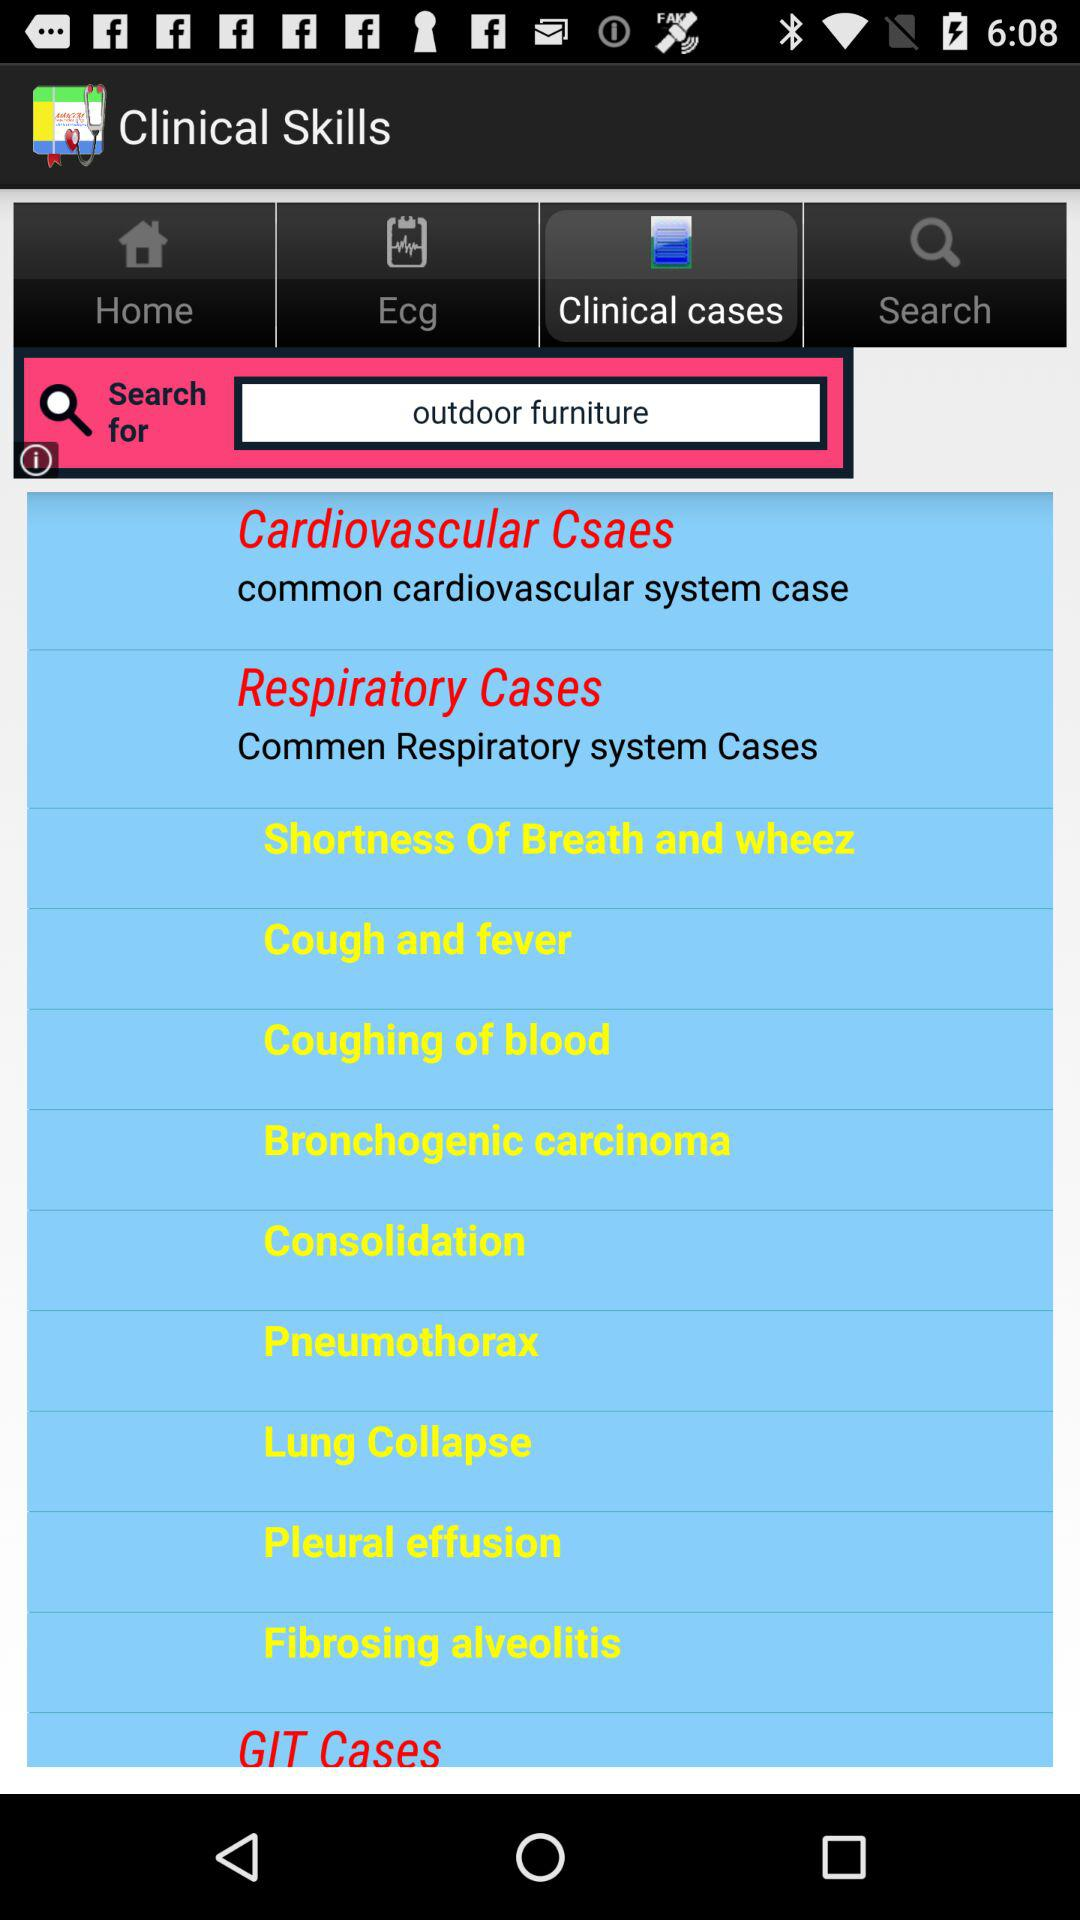What are the available clinical cases? The available clinical cases are Cardiovascular Cases, Respiratory Cases and GIT Cases. 